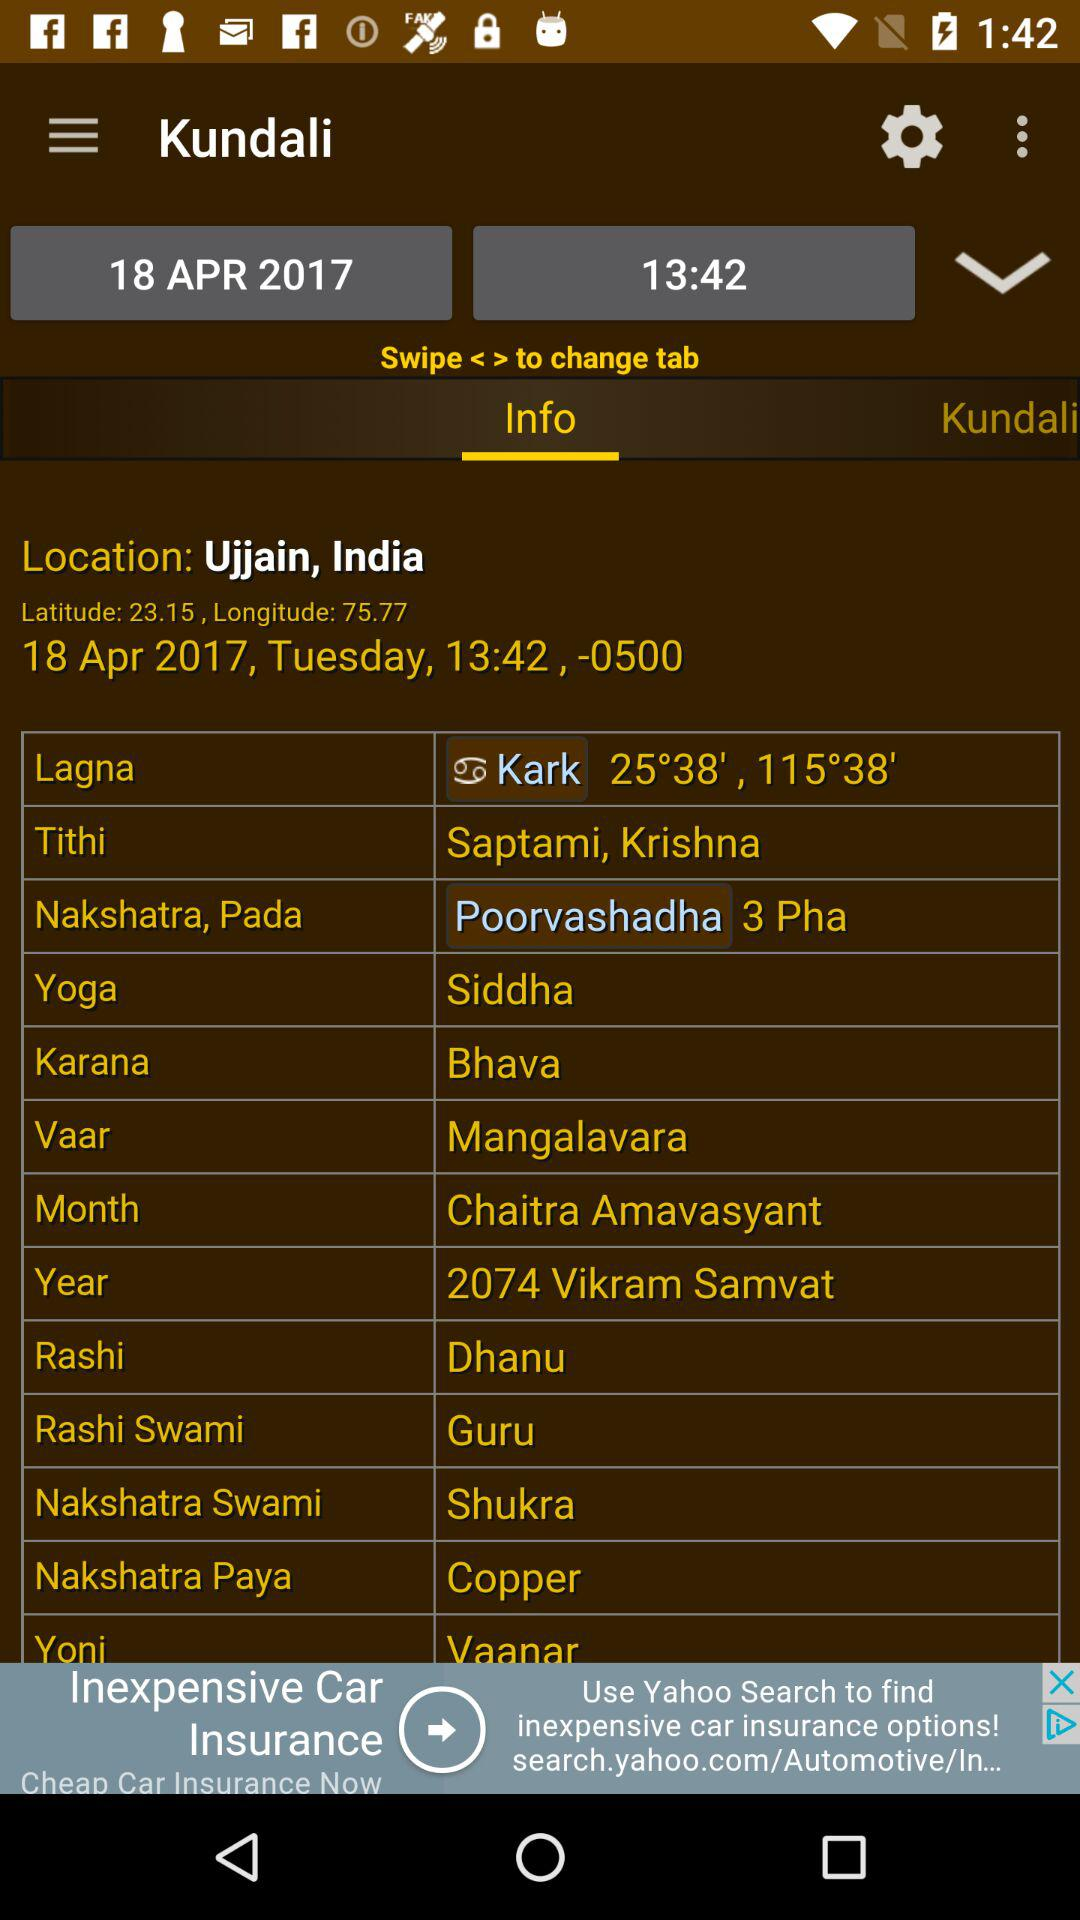What is the latitude coordinate? The latitude coordinate is 23.15. 